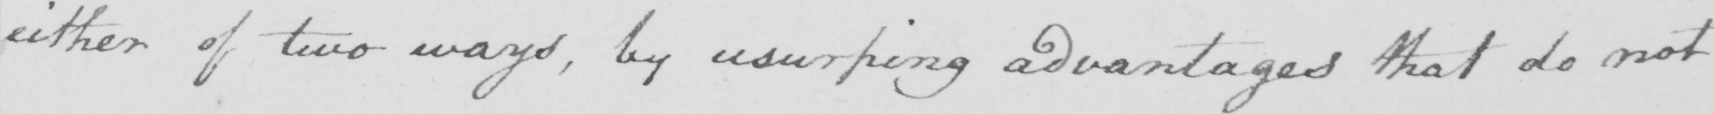What does this handwritten line say? either of two ways, by usurping advantages that do not 